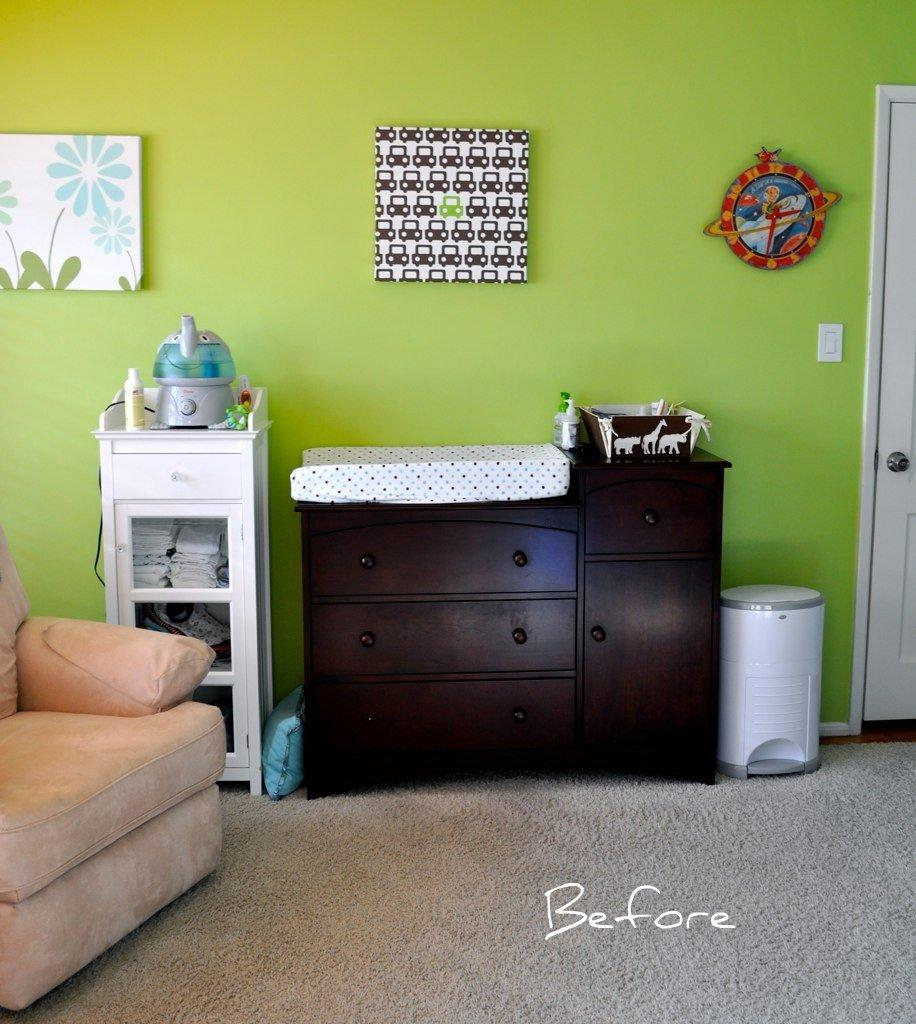<image>
Describe the image concisely. a room that has a before word on the bottom of it 